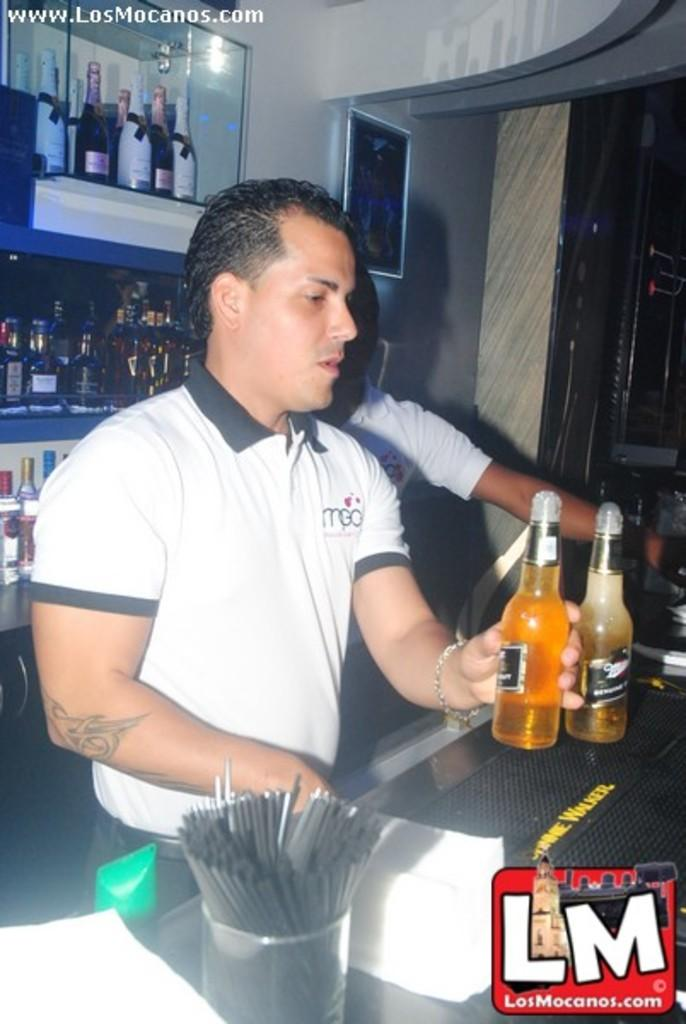What is the guy in the image holding? The guy is holding a bottle of beer in the image. Can you describe the other person in the image? There is a man standing behind the guy. What can be seen on the rack in the image? The rack contains champagne, wines, and beers. How many dimes are on the rack in the image? There are no dimes present on the rack in the image; it contains champagne, wines, and beers. What emotion is the guy displaying in the image? The provided facts do not mention the guy's emotions, so it cannot be determined from the image. 